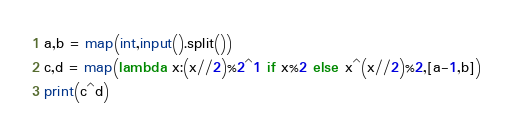<code> <loc_0><loc_0><loc_500><loc_500><_Python_>a,b = map(int,input().split())
c,d = map(lambda x:(x//2)%2^1 if x%2 else x^(x//2)%2,[a-1,b])
print(c^d)</code> 